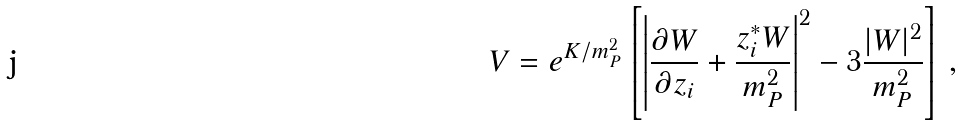Convert formula to latex. <formula><loc_0><loc_0><loc_500><loc_500>V = e ^ { K / m ^ { 2 } _ { P } } \left [ \left | \frac { \partial W } { \partial z _ { i } } + \frac { z ^ { * } _ { i } W } { m ^ { 2 } _ { P } } \right | ^ { 2 } - 3 \frac { | W | ^ { 2 } } { m ^ { 2 } _ { P } } \right ] \, ,</formula> 